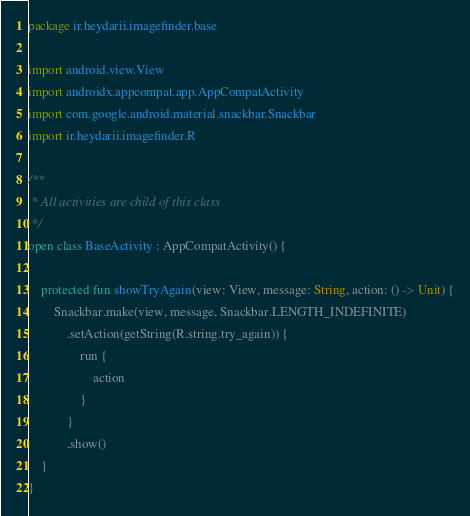<code> <loc_0><loc_0><loc_500><loc_500><_Kotlin_>package ir.heydarii.imagefinder.base

import android.view.View
import androidx.appcompat.app.AppCompatActivity
import com.google.android.material.snackbar.Snackbar
import ir.heydarii.imagefinder.R

/**
 * All activities are child of this class
 */
open class BaseActivity : AppCompatActivity() {

    protected fun showTryAgain(view: View, message: String, action: () -> Unit) {
        Snackbar.make(view, message, Snackbar.LENGTH_INDEFINITE)
            .setAction(getString(R.string.try_again)) {
                run {
                    action
                }
            }
            .show()
    }
}
</code> 